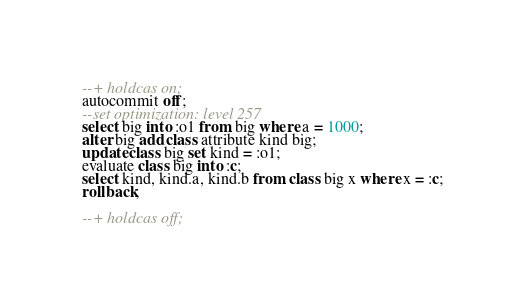<code> <loc_0><loc_0><loc_500><loc_500><_SQL_>--+ holdcas on;
autocommit off;
--set optimization: level 257
select big into :o1 from big where a = 1000;
alter big add class attribute kind big;
update class big set kind = :o1;
evaluate class big into :c;
select kind, kind.a, kind.b from class big x where x = :c;
rollback;

--+ holdcas off;
</code> 